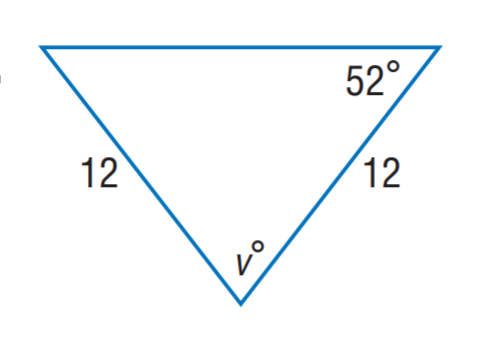Question: Find m \angle v.
Choices:
A. 12
B. 52
C. 68
D. 76
Answer with the letter. Answer: D 